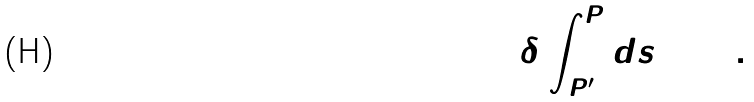Convert formula to latex. <formula><loc_0><loc_0><loc_500><loc_500>\delta \int _ { P ^ { \prime } } ^ { P } d s = 0 \, .</formula> 